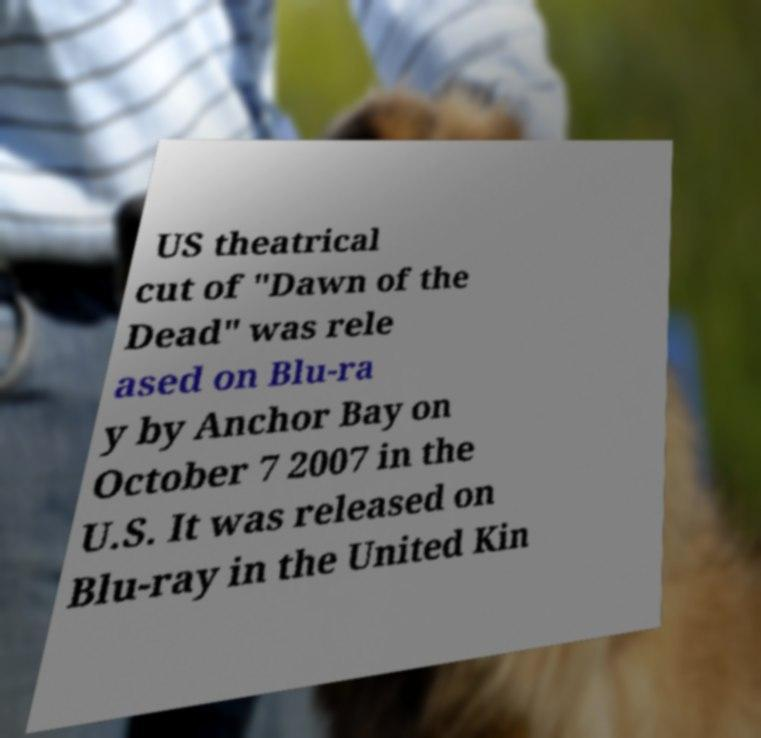There's text embedded in this image that I need extracted. Can you transcribe it verbatim? US theatrical cut of "Dawn of the Dead" was rele ased on Blu-ra y by Anchor Bay on October 7 2007 in the U.S. It was released on Blu-ray in the United Kin 